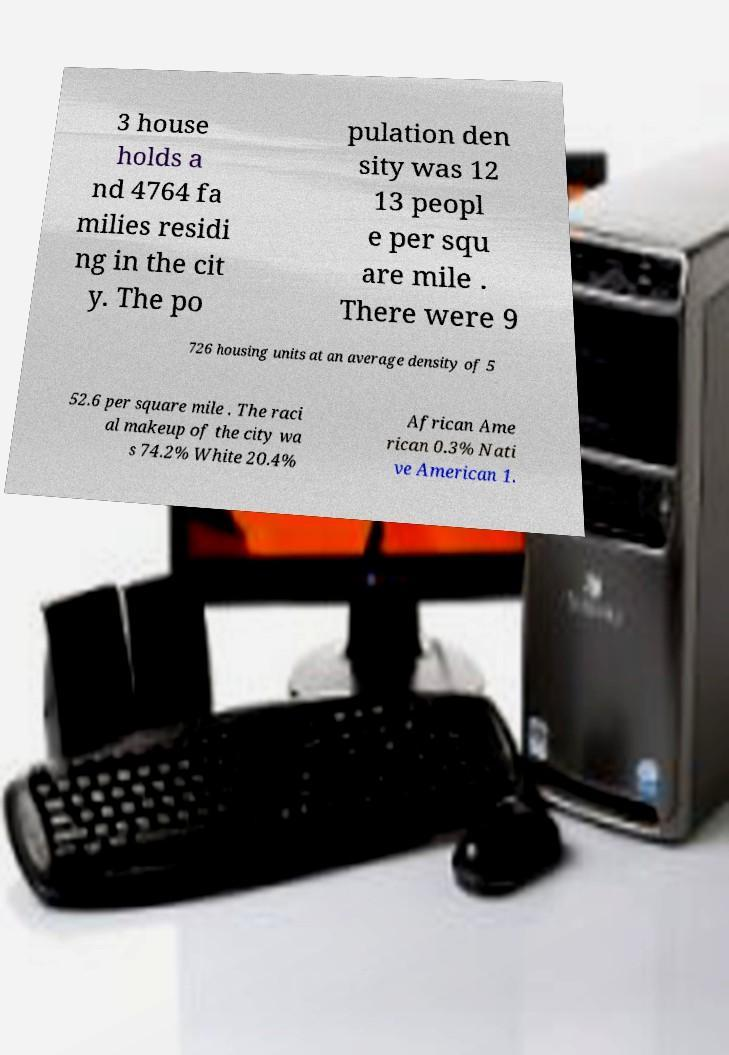Please read and relay the text visible in this image. What does it say? 3 house holds a nd 4764 fa milies residi ng in the cit y. The po pulation den sity was 12 13 peopl e per squ are mile . There were 9 726 housing units at an average density of 5 52.6 per square mile . The raci al makeup of the city wa s 74.2% White 20.4% African Ame rican 0.3% Nati ve American 1. 